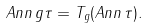Convert formula to latex. <formula><loc_0><loc_0><loc_500><loc_500>A n n \, g \tau = T _ { g } ( A n n \, \tau ) .</formula> 